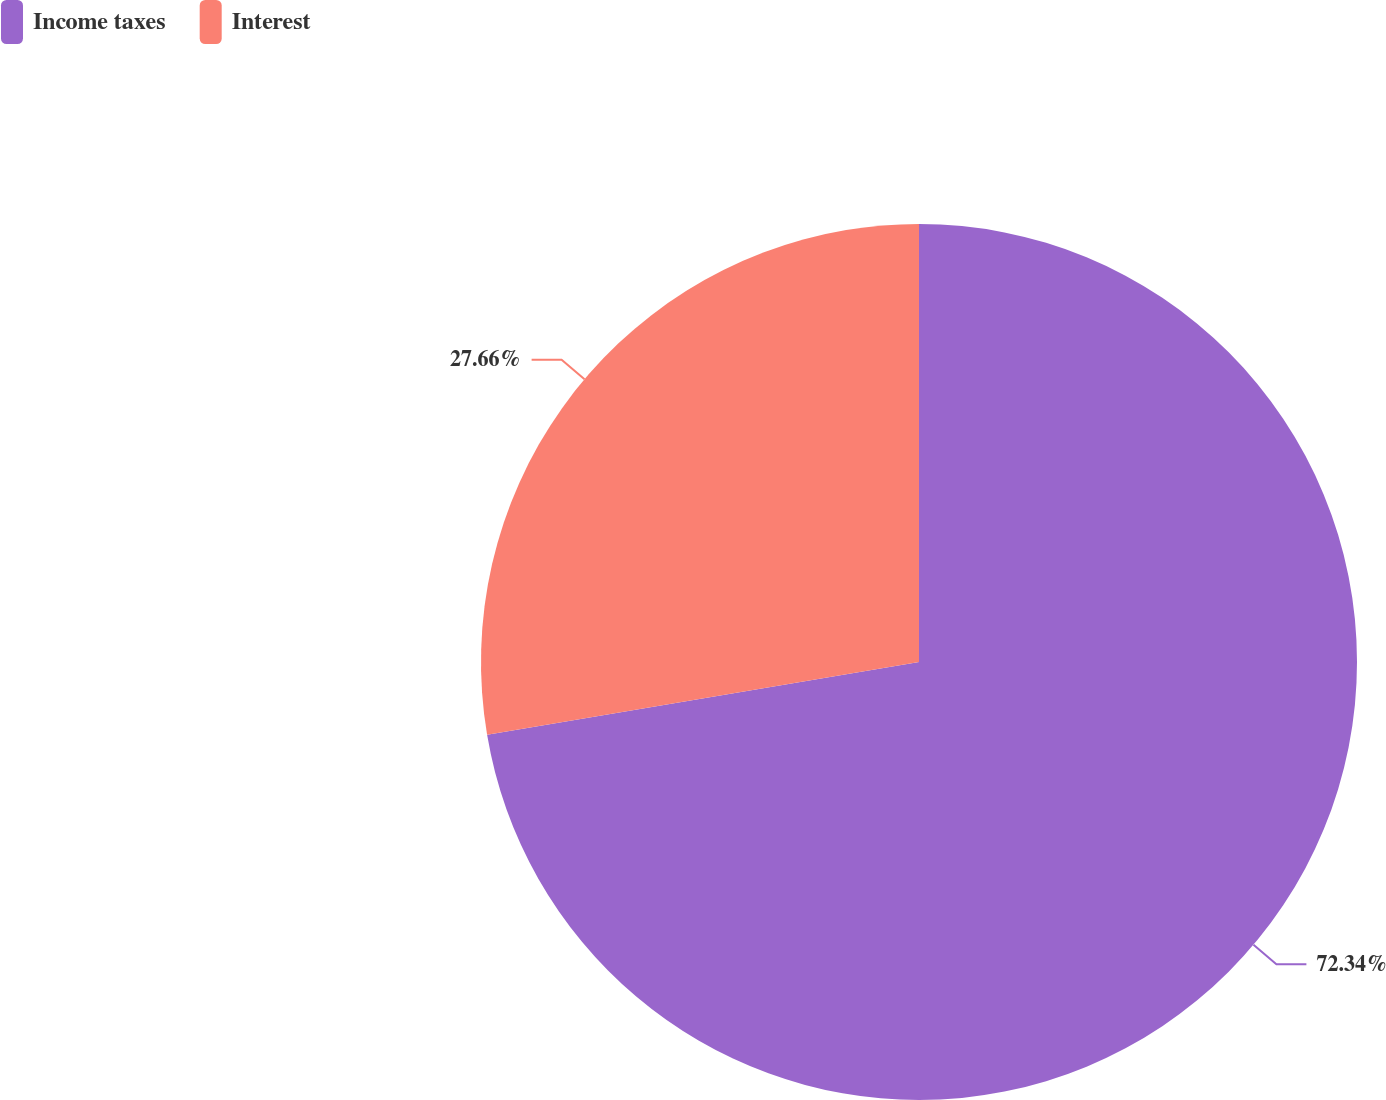<chart> <loc_0><loc_0><loc_500><loc_500><pie_chart><fcel>Income taxes<fcel>Interest<nl><fcel>72.34%<fcel>27.66%<nl></chart> 